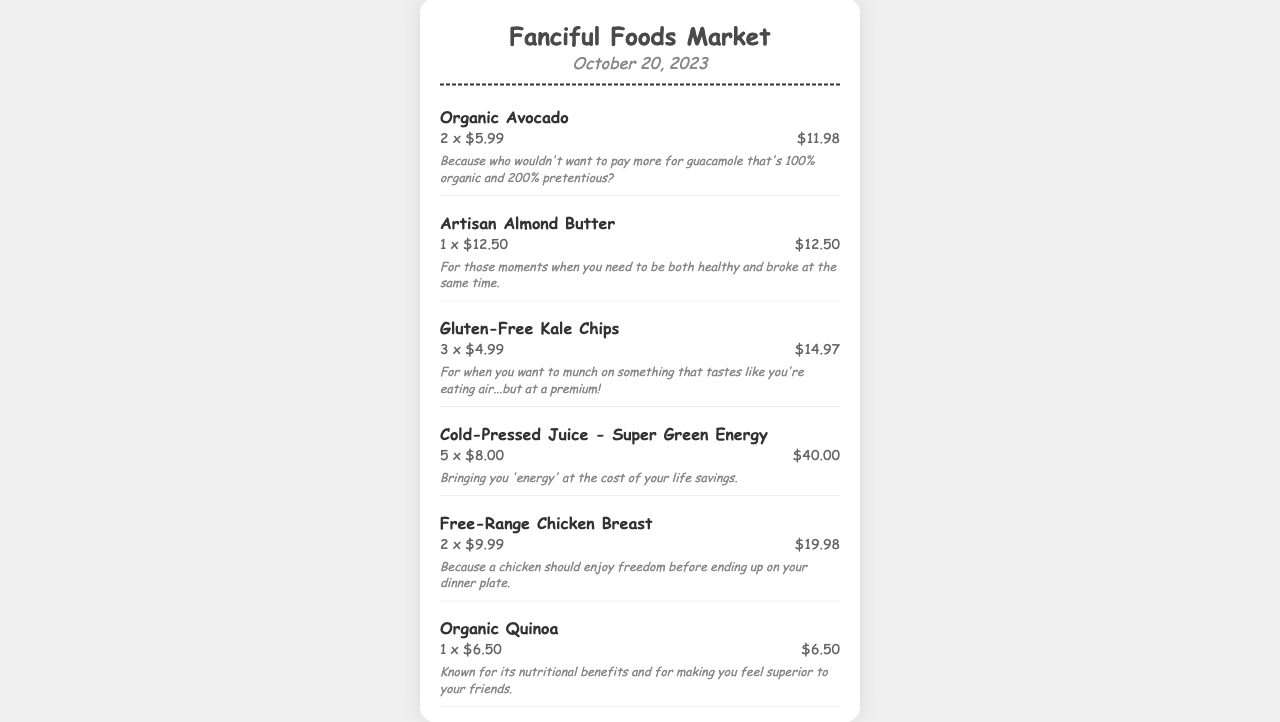What is the store name? The store name is prominently displayed at the top of the receipt.
Answer: Fanciful Foods Market What is the date of the receipt? The date is shown beneath the store name.
Answer: October 20, 2023 How much are the organic avocados? The price for organic avocados is indicated next to the item details.
Answer: $5.99 How many items are listed on the receipt? The number of items can be counted from the itemized list.
Answer: 10 What is the total amount spent? The total is clearly stated at the bottom of the receipt.
Answer: $128.42 What humor is associated with the gluten-free kale chips? The humorous commentary is found under the item details.
Answer: For when you want to munch on something that tastes like you're eating air...but at a premium! How many cold-pressed juices were purchased? The quantity is listed alongside the price for the cold-pressed juice.
Answer: 5 What is the price per unit for artisan almond butter? The price per unit is indicated in the item details section.
Answer: $12.50 How many free-range chicken breasts were bought? The number of chicken breasts can be found in the item details.
Answer: 2 